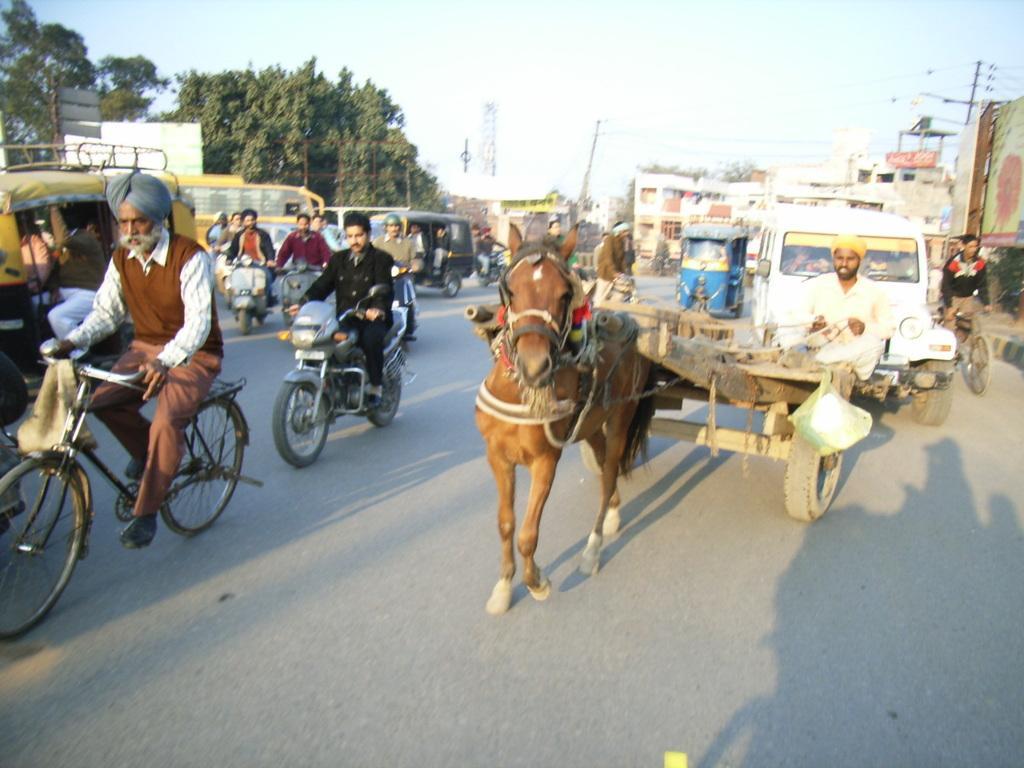Could you give a brief overview of what you see in this image? In this image we can see people, riding bicycles, motorcycles, horse cart, and other vehicles, there are buildings, electric poles, wires, there are trees, also we can see the sky.  